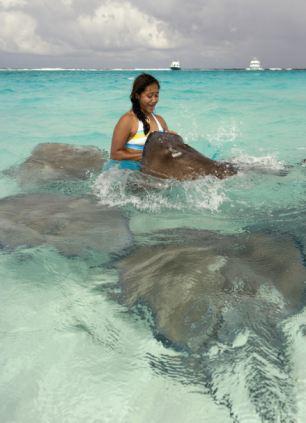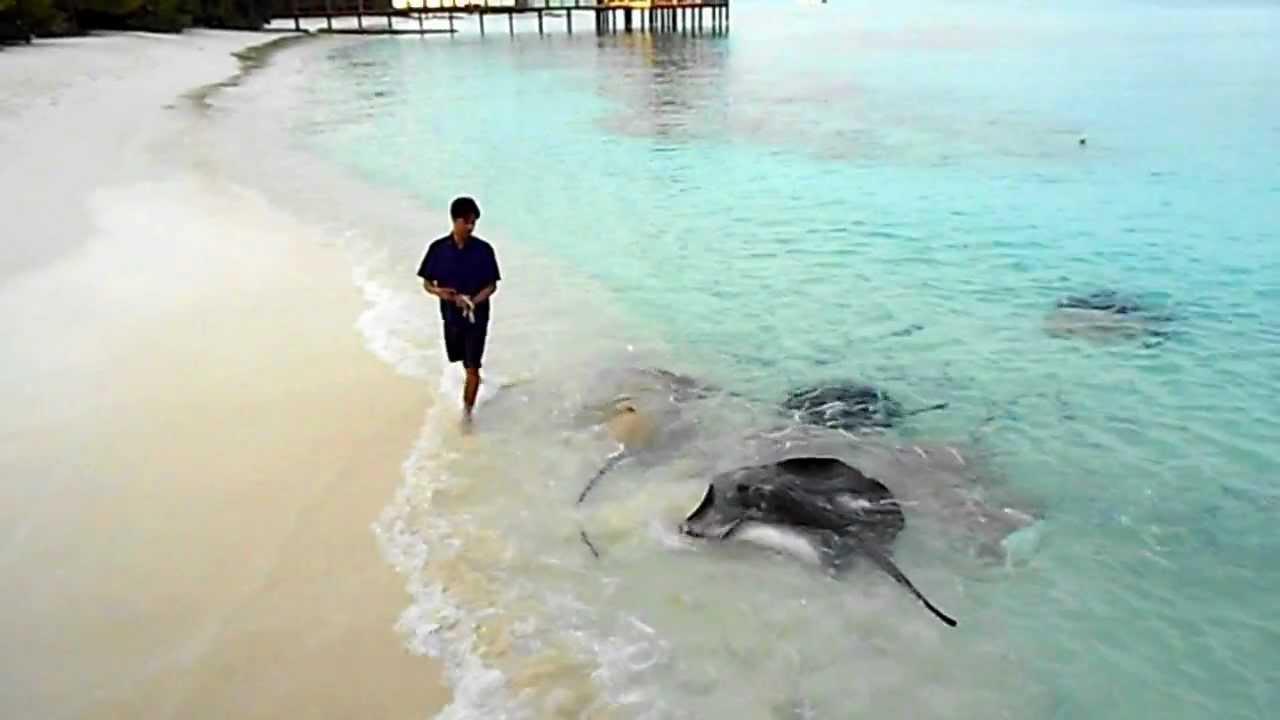The first image is the image on the left, the second image is the image on the right. Analyze the images presented: Is the assertion "At least one person is interacting with a marine animal at the water's surface." valid? Answer yes or no. Yes. The first image is the image on the left, the second image is the image on the right. Assess this claim about the two images: "There is a close up of human hands petting the stingrays.". Correct or not? Answer yes or no. No. 